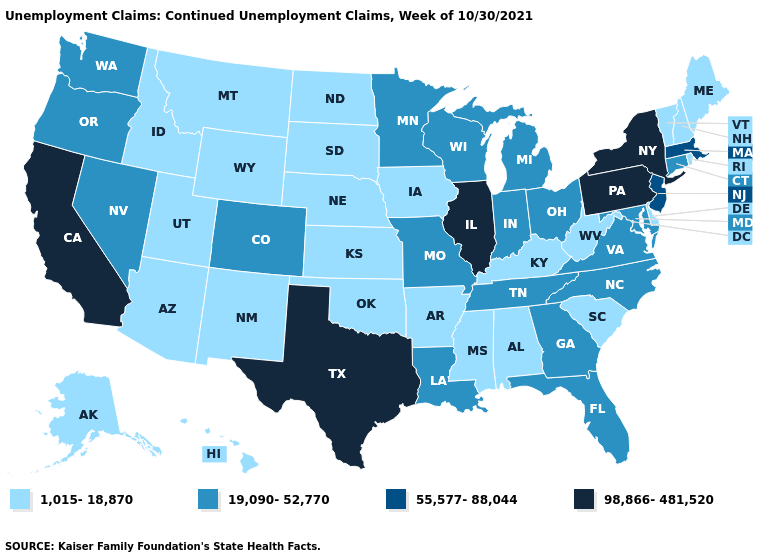What is the highest value in the Northeast ?
Be succinct. 98,866-481,520. Name the states that have a value in the range 1,015-18,870?
Quick response, please. Alabama, Alaska, Arizona, Arkansas, Delaware, Hawaii, Idaho, Iowa, Kansas, Kentucky, Maine, Mississippi, Montana, Nebraska, New Hampshire, New Mexico, North Dakota, Oklahoma, Rhode Island, South Carolina, South Dakota, Utah, Vermont, West Virginia, Wyoming. Name the states that have a value in the range 55,577-88,044?
Short answer required. Massachusetts, New Jersey. Among the states that border New York , which have the lowest value?
Be succinct. Vermont. Which states have the lowest value in the West?
Answer briefly. Alaska, Arizona, Hawaii, Idaho, Montana, New Mexico, Utah, Wyoming. Name the states that have a value in the range 98,866-481,520?
Short answer required. California, Illinois, New York, Pennsylvania, Texas. What is the value of Washington?
Keep it brief. 19,090-52,770. Among the states that border Wyoming , does Montana have the lowest value?
Write a very short answer. Yes. What is the highest value in the MidWest ?
Concise answer only. 98,866-481,520. Name the states that have a value in the range 98,866-481,520?
Answer briefly. California, Illinois, New York, Pennsylvania, Texas. What is the highest value in the West ?
Concise answer only. 98,866-481,520. Is the legend a continuous bar?
Be succinct. No. Name the states that have a value in the range 19,090-52,770?
Keep it brief. Colorado, Connecticut, Florida, Georgia, Indiana, Louisiana, Maryland, Michigan, Minnesota, Missouri, Nevada, North Carolina, Ohio, Oregon, Tennessee, Virginia, Washington, Wisconsin. What is the lowest value in the South?
Keep it brief. 1,015-18,870. What is the lowest value in the USA?
Write a very short answer. 1,015-18,870. 